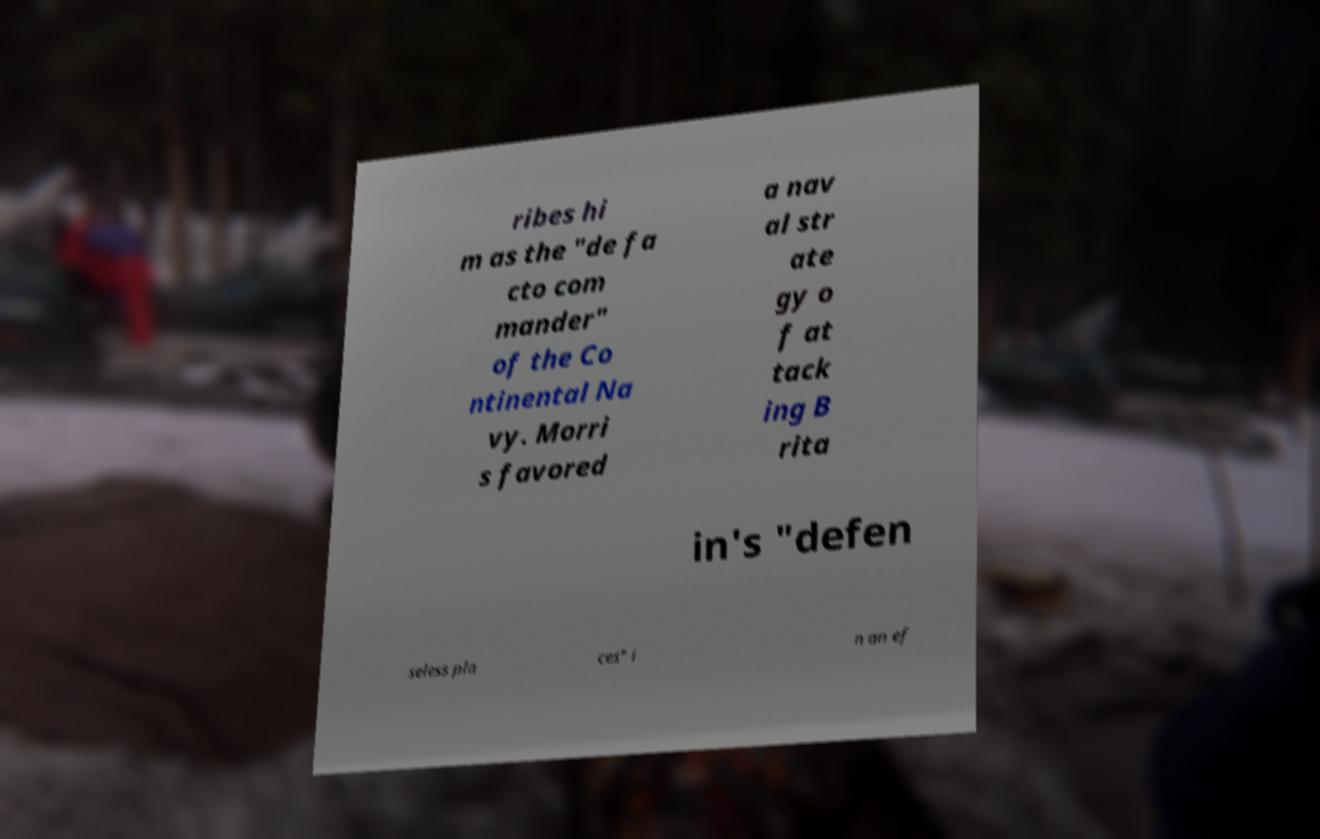Could you assist in decoding the text presented in this image and type it out clearly? ribes hi m as the "de fa cto com mander" of the Co ntinental Na vy. Morri s favored a nav al str ate gy o f at tack ing B rita in's "defen seless pla ces" i n an ef 